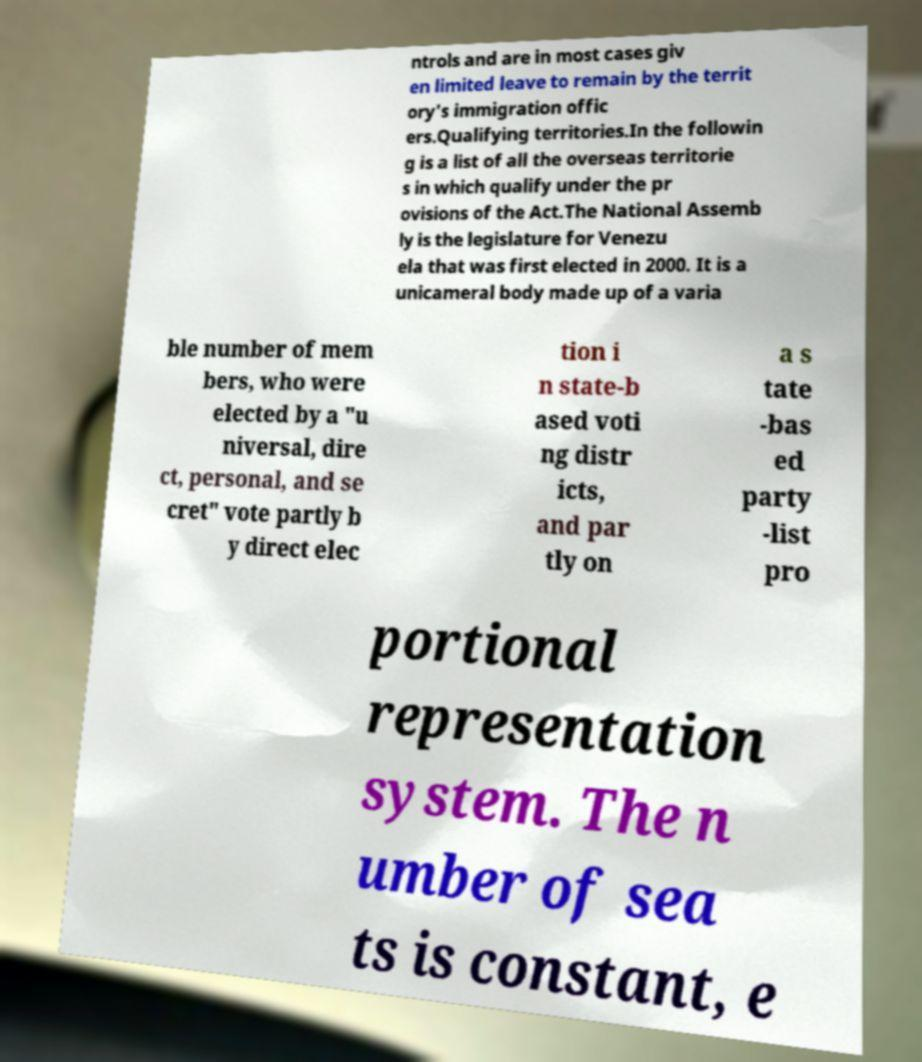What messages or text are displayed in this image? I need them in a readable, typed format. ntrols and are in most cases giv en limited leave to remain by the territ ory's immigration offic ers.Qualifying territories.In the followin g is a list of all the overseas territorie s in which qualify under the pr ovisions of the Act.The National Assemb ly is the legislature for Venezu ela that was first elected in 2000. It is a unicameral body made up of a varia ble number of mem bers, who were elected by a "u niversal, dire ct, personal, and se cret" vote partly b y direct elec tion i n state-b ased voti ng distr icts, and par tly on a s tate -bas ed party -list pro portional representation system. The n umber of sea ts is constant, e 